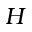Convert formula to latex. <formula><loc_0><loc_0><loc_500><loc_500>H</formula> 